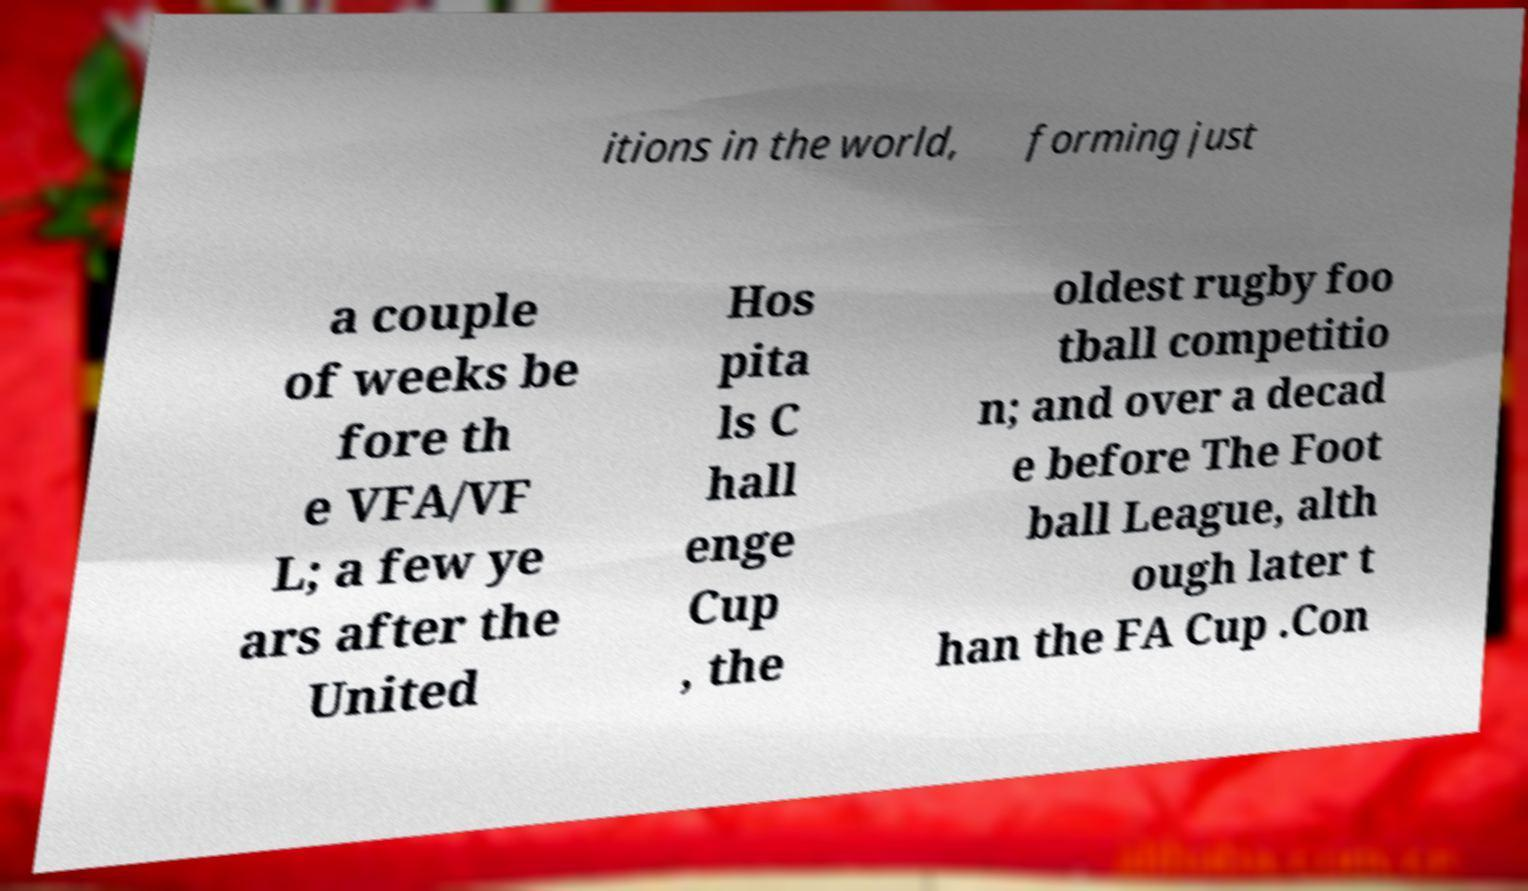I need the written content from this picture converted into text. Can you do that? itions in the world, forming just a couple of weeks be fore th e VFA/VF L; a few ye ars after the United Hos pita ls C hall enge Cup , the oldest rugby foo tball competitio n; and over a decad e before The Foot ball League, alth ough later t han the FA Cup .Con 